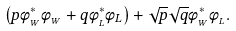Convert formula to latex. <formula><loc_0><loc_0><loc_500><loc_500>\left ( p \phi _ { _ { W } } ^ { \ast } \phi _ { _ { W } } + q \phi _ { _ { L } } ^ { \ast } \phi _ { L } \right ) + \sqrt { p } \sqrt { q } \phi _ { _ { W } } ^ { \ast } \phi _ { _ { L } } .</formula> 